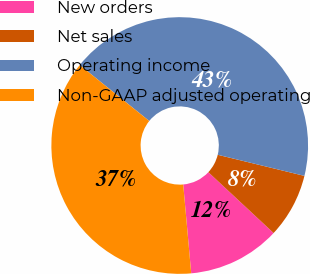<chart> <loc_0><loc_0><loc_500><loc_500><pie_chart><fcel>New orders<fcel>Net sales<fcel>Operating income<fcel>Non-GAAP adjusted operating<nl><fcel>11.63%<fcel>8.14%<fcel>43.02%<fcel>37.21%<nl></chart> 